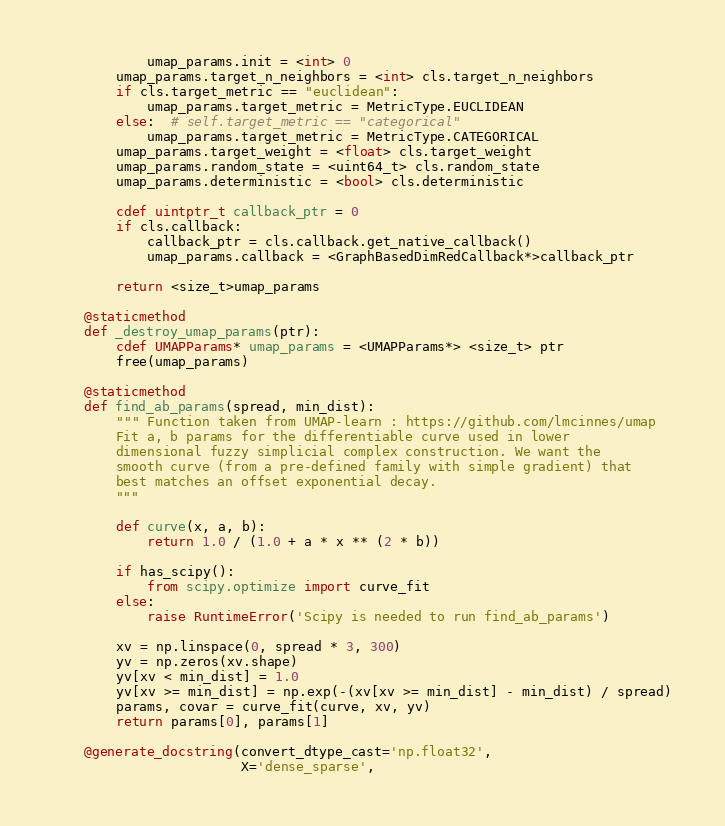<code> <loc_0><loc_0><loc_500><loc_500><_Cython_>            umap_params.init = <int> 0
        umap_params.target_n_neighbors = <int> cls.target_n_neighbors
        if cls.target_metric == "euclidean":
            umap_params.target_metric = MetricType.EUCLIDEAN
        else:  # self.target_metric == "categorical"
            umap_params.target_metric = MetricType.CATEGORICAL
        umap_params.target_weight = <float> cls.target_weight
        umap_params.random_state = <uint64_t> cls.random_state
        umap_params.deterministic = <bool> cls.deterministic

        cdef uintptr_t callback_ptr = 0
        if cls.callback:
            callback_ptr = cls.callback.get_native_callback()
            umap_params.callback = <GraphBasedDimRedCallback*>callback_ptr

        return <size_t>umap_params

    @staticmethod
    def _destroy_umap_params(ptr):
        cdef UMAPParams* umap_params = <UMAPParams*> <size_t> ptr
        free(umap_params)

    @staticmethod
    def find_ab_params(spread, min_dist):
        """ Function taken from UMAP-learn : https://github.com/lmcinnes/umap
        Fit a, b params for the differentiable curve used in lower
        dimensional fuzzy simplicial complex construction. We want the
        smooth curve (from a pre-defined family with simple gradient) that
        best matches an offset exponential decay.
        """

        def curve(x, a, b):
            return 1.0 / (1.0 + a * x ** (2 * b))

        if has_scipy():
            from scipy.optimize import curve_fit
        else:
            raise RuntimeError('Scipy is needed to run find_ab_params')

        xv = np.linspace(0, spread * 3, 300)
        yv = np.zeros(xv.shape)
        yv[xv < min_dist] = 1.0
        yv[xv >= min_dist] = np.exp(-(xv[xv >= min_dist] - min_dist) / spread)
        params, covar = curve_fit(curve, xv, yv)
        return params[0], params[1]

    @generate_docstring(convert_dtype_cast='np.float32',
                        X='dense_sparse',</code> 